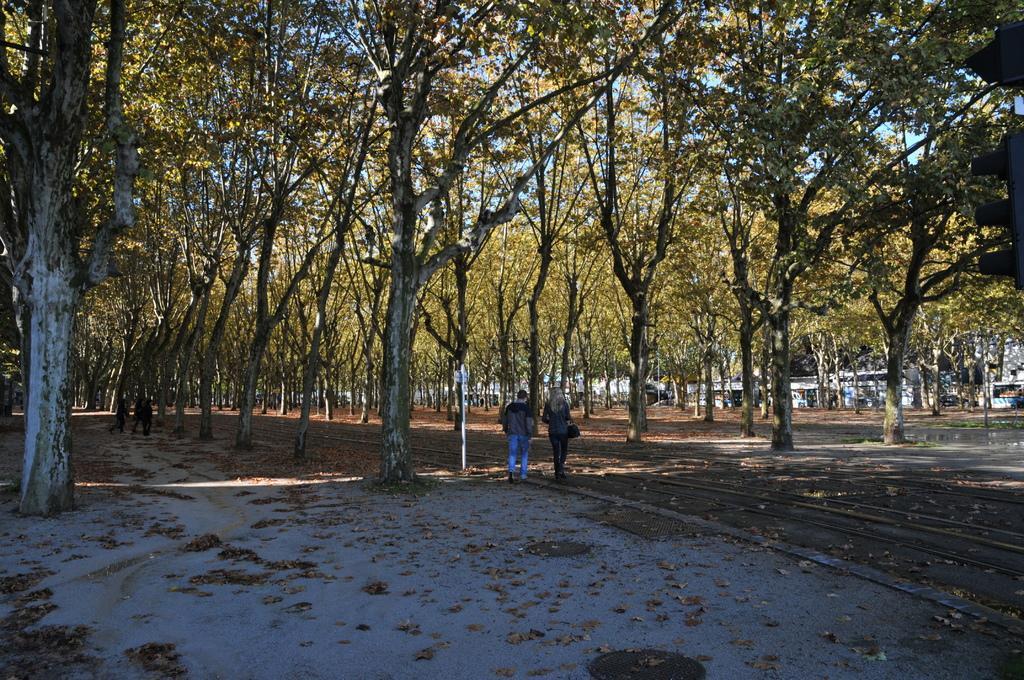How would you summarize this image in a sentence or two? In this image we can see some trees, people, houses and other objects. In the background of the image there is the sky. At the bottom of the image there is the floor. 